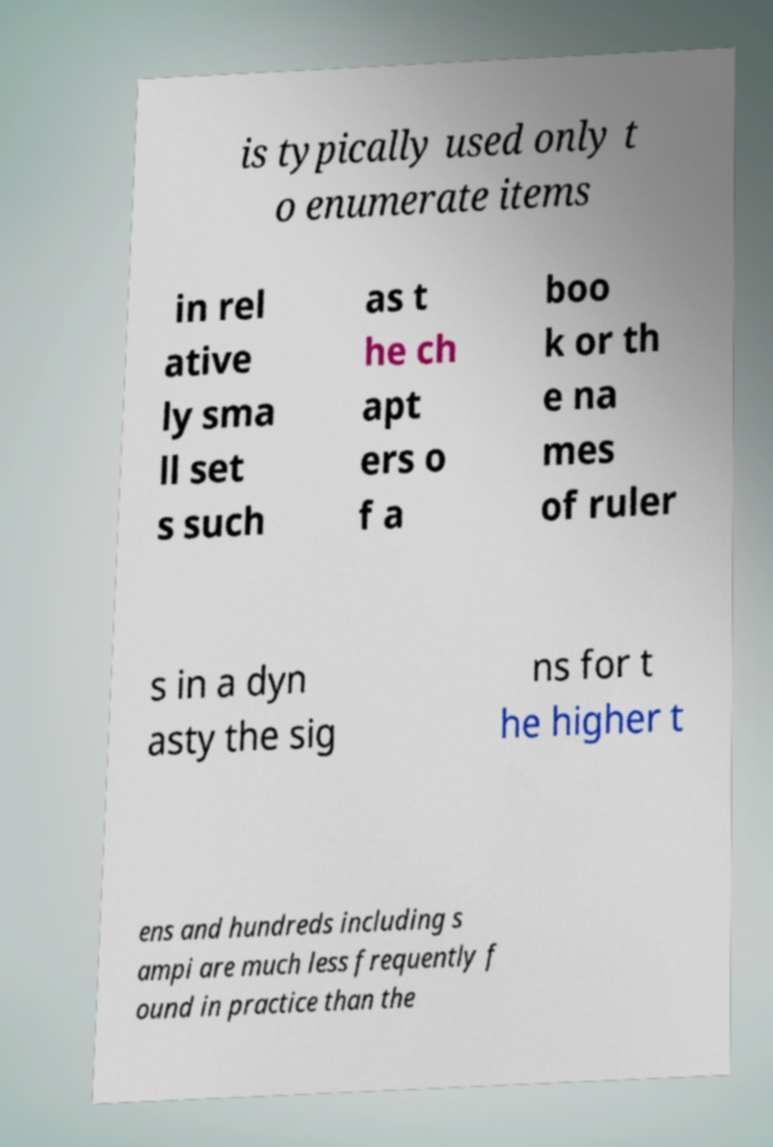For documentation purposes, I need the text within this image transcribed. Could you provide that? is typically used only t o enumerate items in rel ative ly sma ll set s such as t he ch apt ers o f a boo k or th e na mes of ruler s in a dyn asty the sig ns for t he higher t ens and hundreds including s ampi are much less frequently f ound in practice than the 